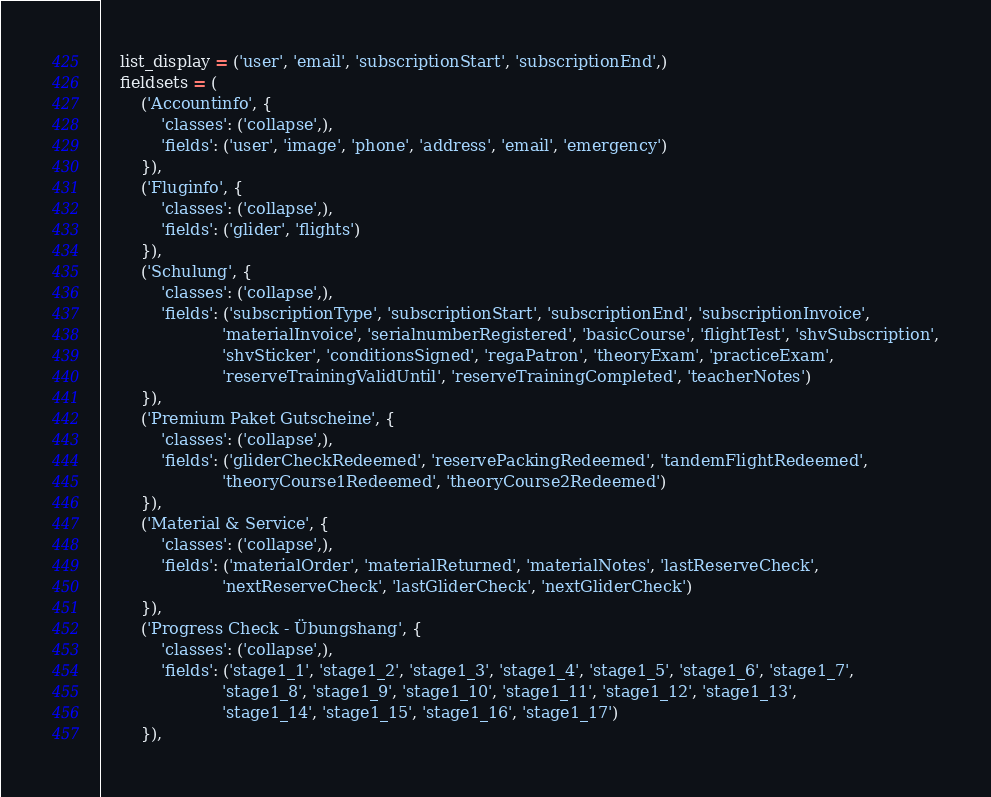<code> <loc_0><loc_0><loc_500><loc_500><_Python_>    list_display = ('user', 'email', 'subscriptionStart', 'subscriptionEnd',)
    fieldsets = (
        ('Accountinfo', {
            'classes': ('collapse',),
            'fields': ('user', 'image', 'phone', 'address', 'email', 'emergency')
        }),
        ('Fluginfo', {
            'classes': ('collapse',),
            'fields': ('glider', 'flights')
        }),
        ('Schulung', {
            'classes': ('collapse',),
            'fields': ('subscriptionType', 'subscriptionStart', 'subscriptionEnd', 'subscriptionInvoice',
                        'materialInvoice', 'serialnumberRegistered', 'basicCourse', 'flightTest', 'shvSubscription',
                        'shvSticker', 'conditionsSigned', 'regaPatron', 'theoryExam', 'practiceExam',
                        'reserveTrainingValidUntil', 'reserveTrainingCompleted', 'teacherNotes')
        }),
        ('Premium Paket Gutscheine', {
            'classes': ('collapse',),
            'fields': ('gliderCheckRedeemed', 'reservePackingRedeemed', 'tandemFlightRedeemed',
                        'theoryCourse1Redeemed', 'theoryCourse2Redeemed')
        }),
        ('Material & Service', {
            'classes': ('collapse',),
            'fields': ('materialOrder', 'materialReturned', 'materialNotes', 'lastReserveCheck',
                        'nextReserveCheck', 'lastGliderCheck', 'nextGliderCheck')
        }),
        ('Progress Check - Übungshang', {
            'classes': ('collapse',),
            'fields': ('stage1_1', 'stage1_2', 'stage1_3', 'stage1_4', 'stage1_5', 'stage1_6', 'stage1_7',
                        'stage1_8', 'stage1_9', 'stage1_10', 'stage1_11', 'stage1_12', 'stage1_13',
                        'stage1_14', 'stage1_15', 'stage1_16', 'stage1_17')
        }),</code> 